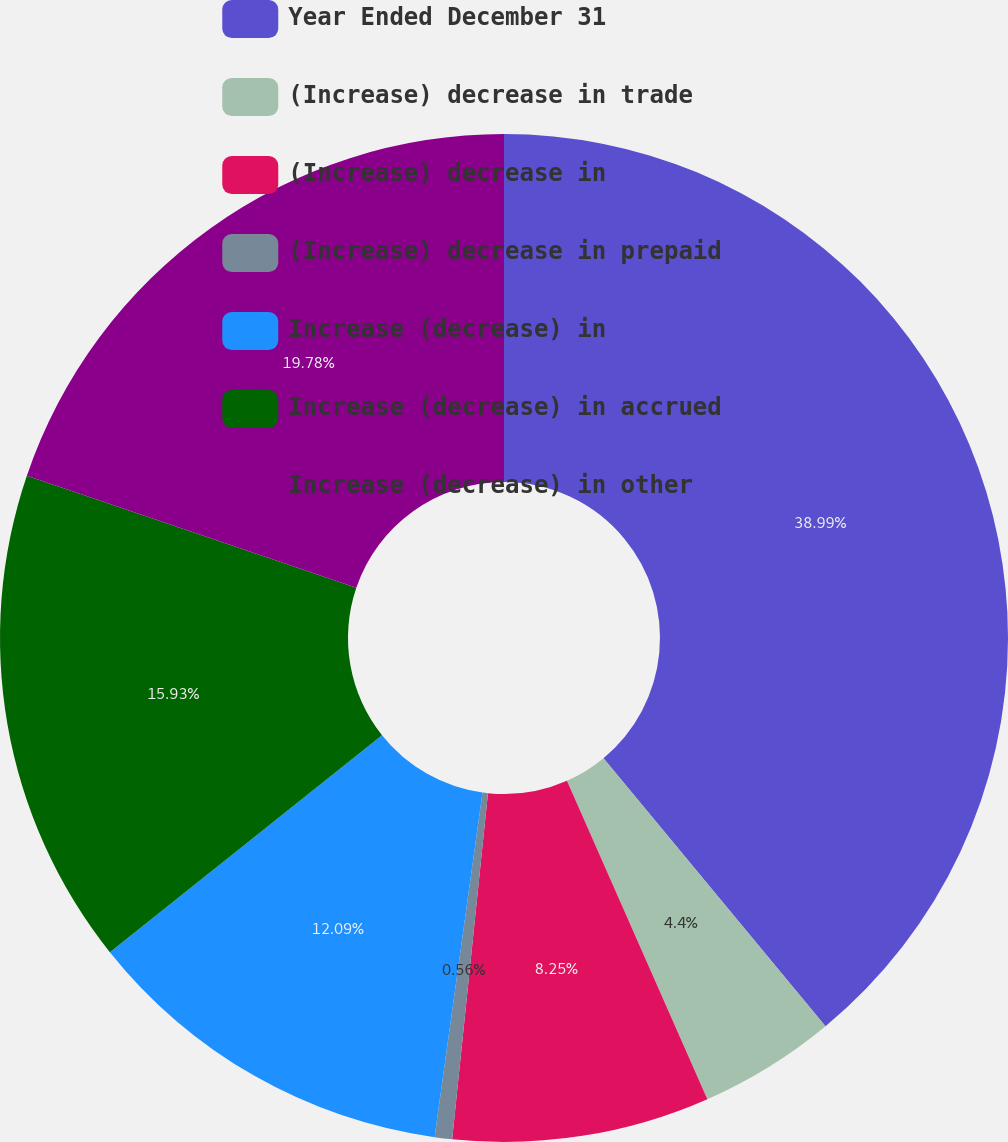Convert chart. <chart><loc_0><loc_0><loc_500><loc_500><pie_chart><fcel>Year Ended December 31<fcel>(Increase) decrease in trade<fcel>(Increase) decrease in<fcel>(Increase) decrease in prepaid<fcel>Increase (decrease) in<fcel>Increase (decrease) in accrued<fcel>Increase (decrease) in other<nl><fcel>38.99%<fcel>4.4%<fcel>8.25%<fcel>0.56%<fcel>12.09%<fcel>15.93%<fcel>19.78%<nl></chart> 